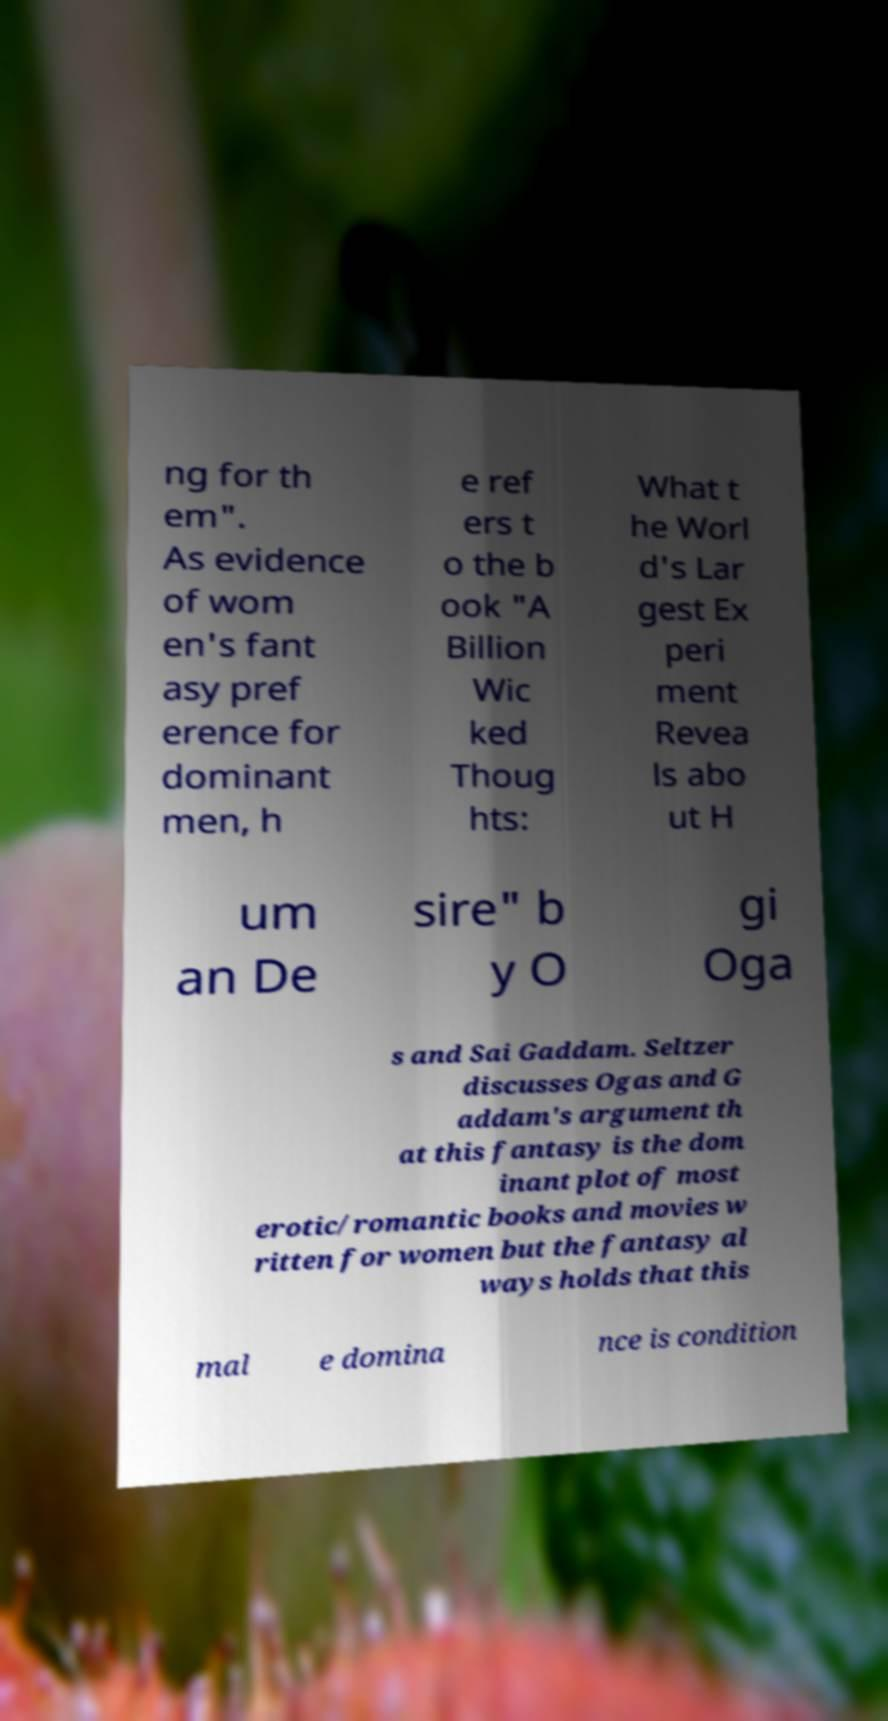Can you accurately transcribe the text from the provided image for me? ng for th em". As evidence of wom en's fant asy pref erence for dominant men, h e ref ers t o the b ook "A Billion Wic ked Thoug hts: What t he Worl d's Lar gest Ex peri ment Revea ls abo ut H um an De sire" b y O gi Oga s and Sai Gaddam. Seltzer discusses Ogas and G addam's argument th at this fantasy is the dom inant plot of most erotic/romantic books and movies w ritten for women but the fantasy al ways holds that this mal e domina nce is condition 